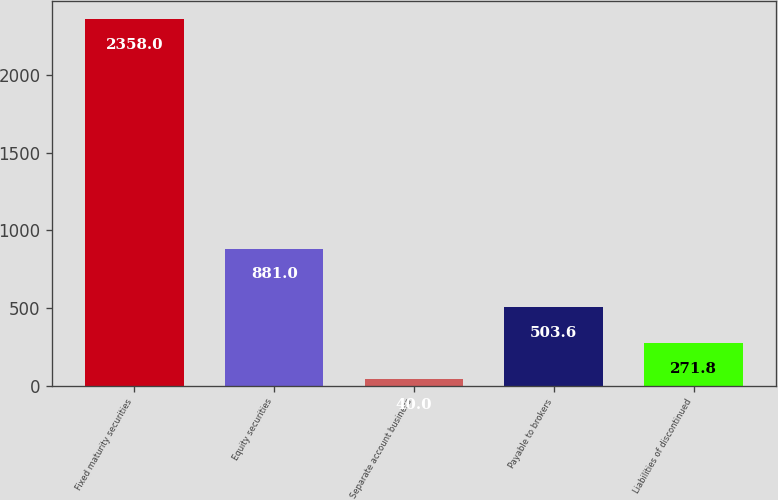<chart> <loc_0><loc_0><loc_500><loc_500><bar_chart><fcel>Fixed maturity securities<fcel>Equity securities<fcel>Separate account business<fcel>Payable to brokers<fcel>Liabilities of discontinued<nl><fcel>2358<fcel>881<fcel>40<fcel>503.6<fcel>271.8<nl></chart> 